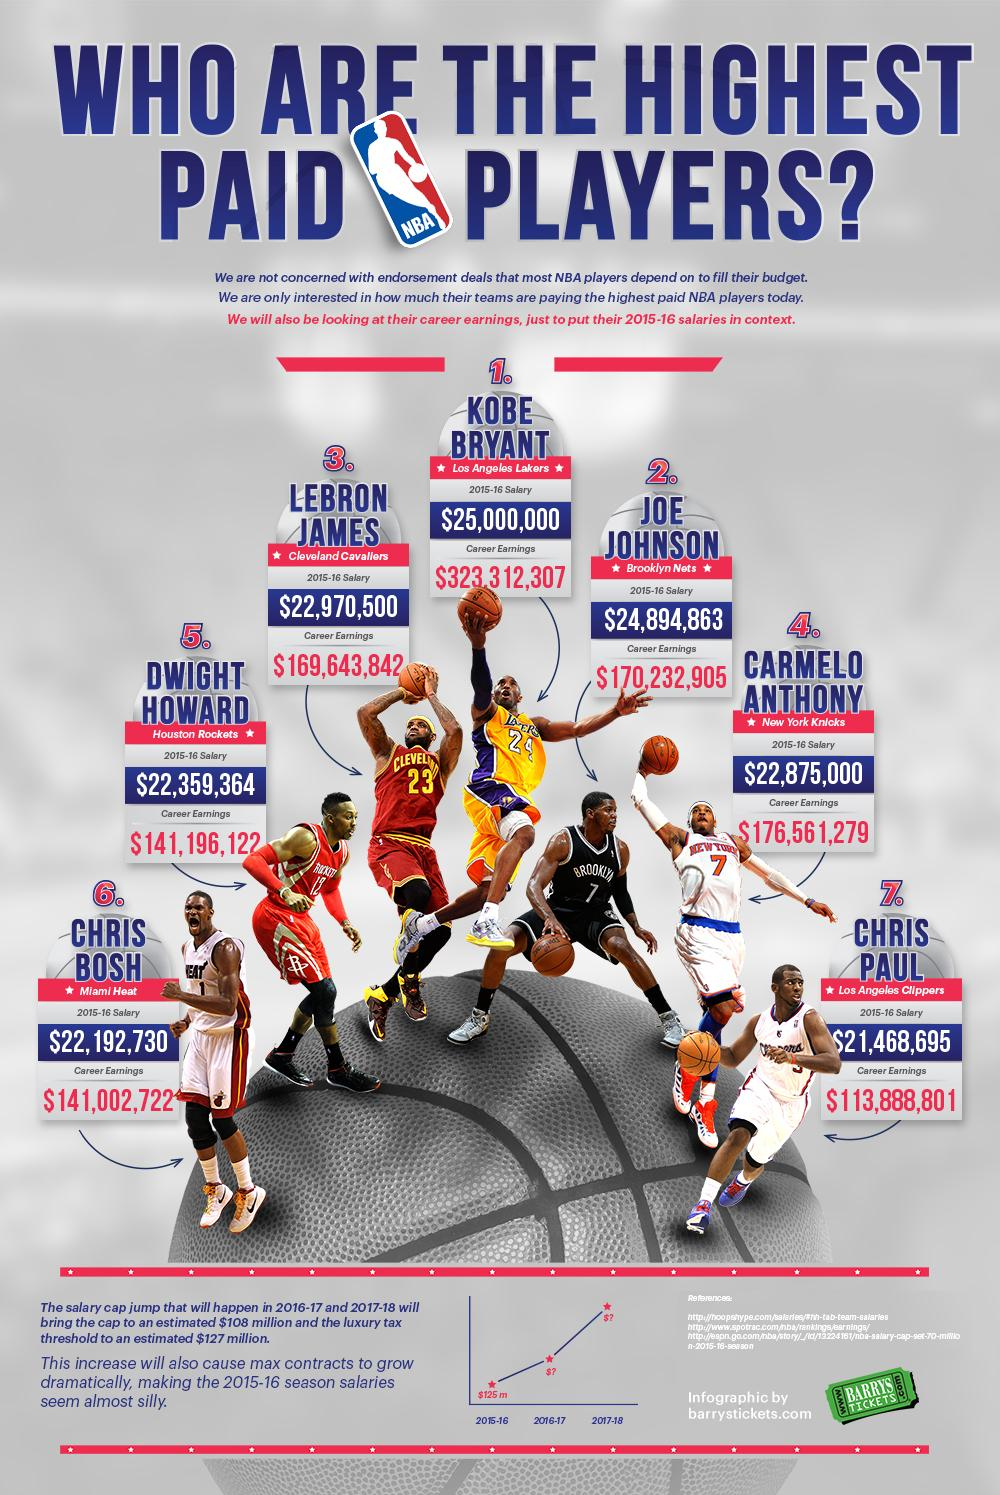Indicate a few pertinent items in this graphic. The number written on Joe Johnson's T-shirt is 7. Chris Bosh belongs to the Miami Heat. As of my knowledge cutoff date of September 2021, Chris Paul has earned a total of $113,888,801 in his career. At position 4, it is Carmelo Anthony. Kobe Bryant's 2015-16 salary was $25,000,000. 